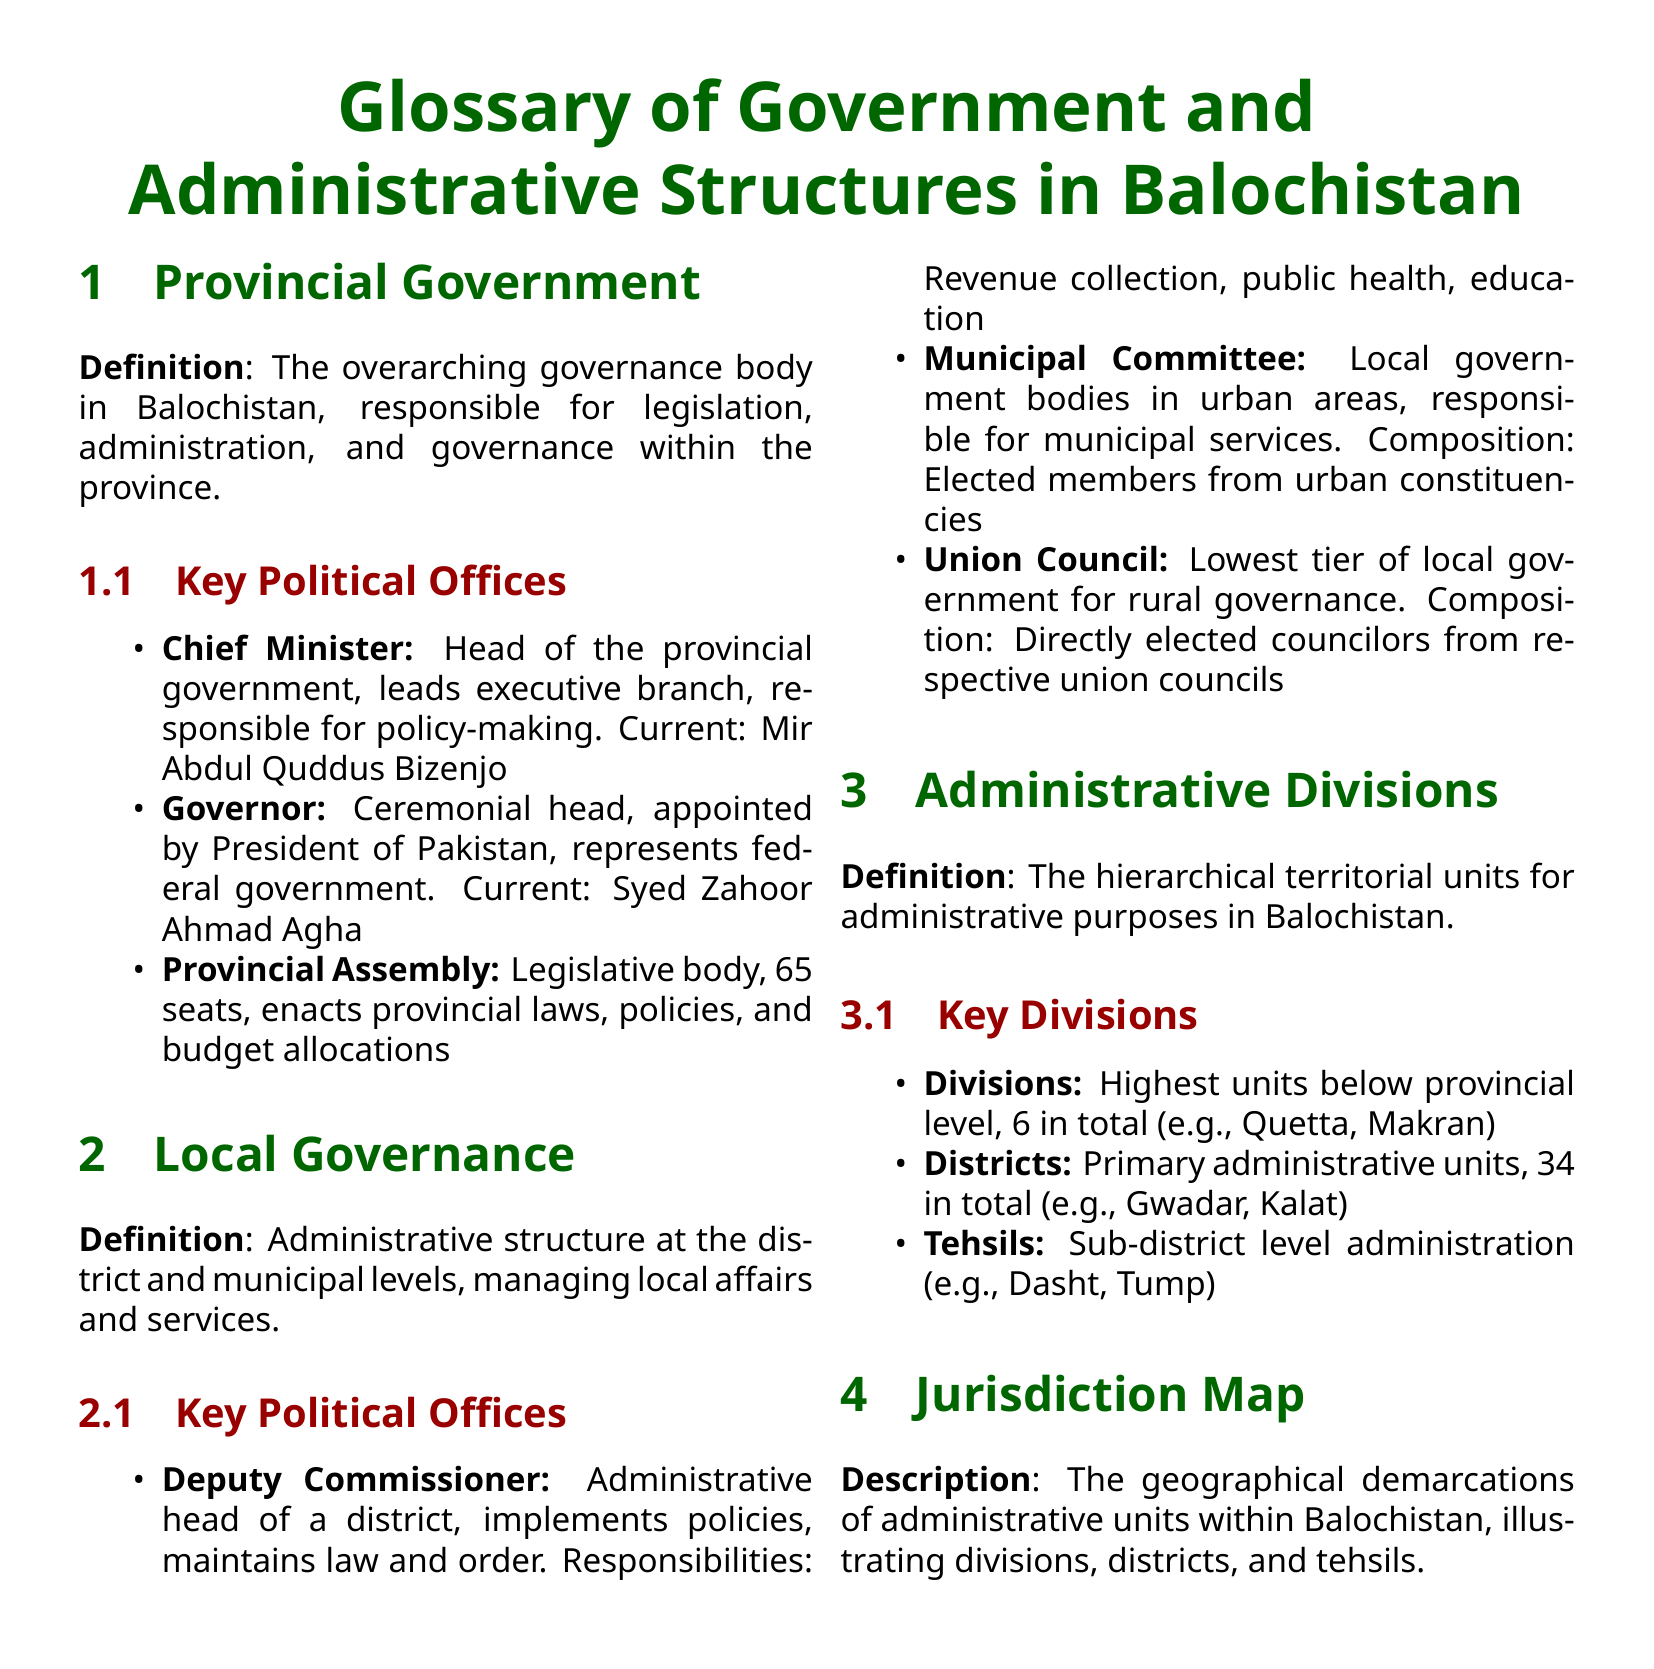What is the current Chief Minister of Balochistan? The Chief Minister is the head of the provincial government, responsible for policy-making. According to the document, the current Chief Minister is Mir Abdul Quddus Bizenjo.
Answer: Mir Abdul Quddus Bizenjo How many seats are in the Provincial Assembly? The Provincial Assembly is responsible for enacting provincial laws, policies, and budget allocations, which consists of 65 seats.
Answer: 65 What is the role of the Deputy Commissioner? The Deputy Commissioner is the administrative head of a district, and their responsibilities include implementing policies and maintaining law and order.
Answer: Administrative head How many divisions are there in Balochistan? Divisions are the highest units below provincial level, with a total of 6 divisions in Balochistan as stated in the document.
Answer: 6 What type of governance does a Municipal Committee provide? A Municipal Committee is responsible for municipal services in urban areas, acting as a local government body.
Answer: Municipal services What is the lowest tier of local government? The document explains that the Union Council represents the lowest tier of local government for rural governance.
Answer: Union Council Who is the current Governor of Balochistan? The Governor serves as the ceremonial head and represents the federal government, with the current Governor being Syed Zahoor Ahmad Agha.
Answer: Syed Zahoor Ahmad Agha How many districts are there in Balochistan? Districts are the primary administrative units in Balochistan, with a total of 34 districts mentioned in the document.
Answer: 34 What is included in the jurisdiction map? The jurisdiction map includes geographical demarcations of administrative units within Balochistan, such as divisions, districts, and tehsils.
Answer: Administrative units 